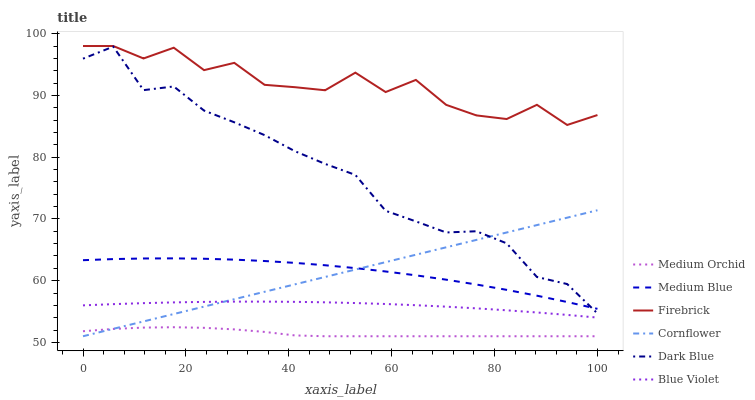Does Medium Orchid have the minimum area under the curve?
Answer yes or no. Yes. Does Firebrick have the maximum area under the curve?
Answer yes or no. Yes. Does Firebrick have the minimum area under the curve?
Answer yes or no. No. Does Medium Orchid have the maximum area under the curve?
Answer yes or no. No. Is Cornflower the smoothest?
Answer yes or no. Yes. Is Firebrick the roughest?
Answer yes or no. Yes. Is Medium Orchid the smoothest?
Answer yes or no. No. Is Medium Orchid the roughest?
Answer yes or no. No. Does Cornflower have the lowest value?
Answer yes or no. Yes. Does Firebrick have the lowest value?
Answer yes or no. No. Does Firebrick have the highest value?
Answer yes or no. Yes. Does Medium Orchid have the highest value?
Answer yes or no. No. Is Dark Blue less than Firebrick?
Answer yes or no. Yes. Is Firebrick greater than Medium Blue?
Answer yes or no. Yes. Does Dark Blue intersect Cornflower?
Answer yes or no. Yes. Is Dark Blue less than Cornflower?
Answer yes or no. No. Is Dark Blue greater than Cornflower?
Answer yes or no. No. Does Dark Blue intersect Firebrick?
Answer yes or no. No. 